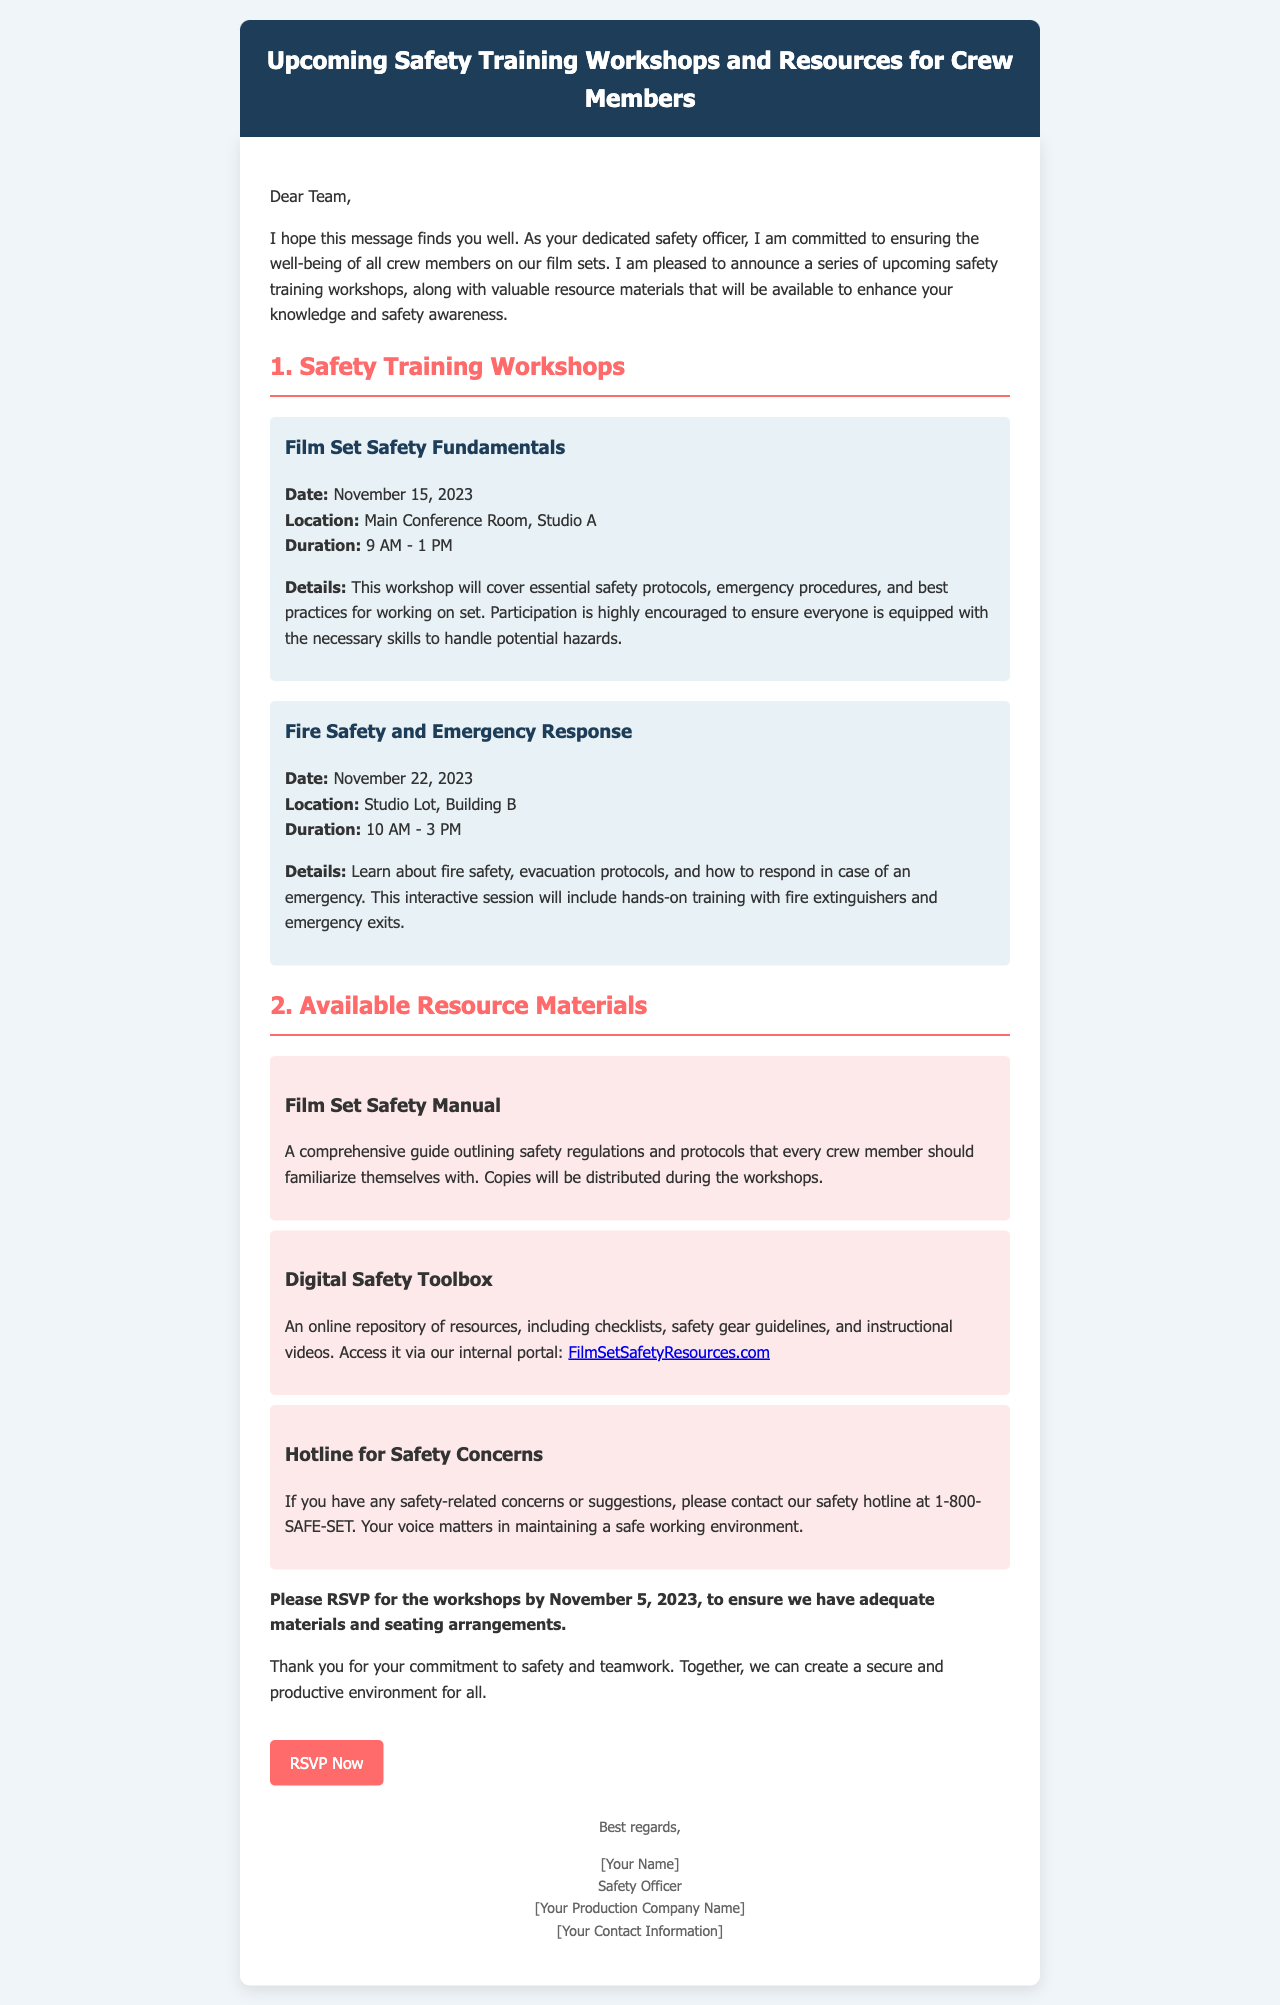What is the date of the "Film Set Safety Fundamentals" workshop? The date is explicitly stated in the workshop details.
Answer: November 15, 2023 What is the duration of the "Fire Safety and Emergency Response" workshop? The workshop details include specific time periods for the events.
Answer: 10 AM - 3 PM Where will the "Film Set Safety Fundamentals" workshop take place? The location is provided in the workshop details.
Answer: Main Conference Room, Studio A What is included in the "Digital Safety Toolbox"? This information is given in the description of the resource materials.
Answer: Online repository of resources When is the RSVP deadline for the workshops? The deadline is clearly mentioned in the closing paragraph of the email.
Answer: November 5, 2023 What is the purpose of the safety hotline? The document specifies the hotline's purpose in relation to maintaining safety.
Answer: Safety-related concerns or suggestions How many workshops are listed in the document? The email lists distinct workshops, and the total is a simple count.
Answer: Two What color is the header background in the email? The style of the email indicates the color used for the header background.
Answer: Dark blue 